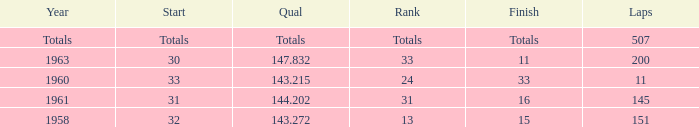Parse the table in full. {'header': ['Year', 'Start', 'Qual', 'Rank', 'Finish', 'Laps'], 'rows': [['Totals', 'Totals', 'Totals', 'Totals', 'Totals', '507'], ['1963', '30', '147.832', '33', '11', '200'], ['1960', '33', '143.215', '24', '33', '11'], ['1961', '31', '144.202', '31', '16', '145'], ['1958', '32', '143.272', '13', '15', '151']]} What year did the finish of 15 happen in? 1958.0. 